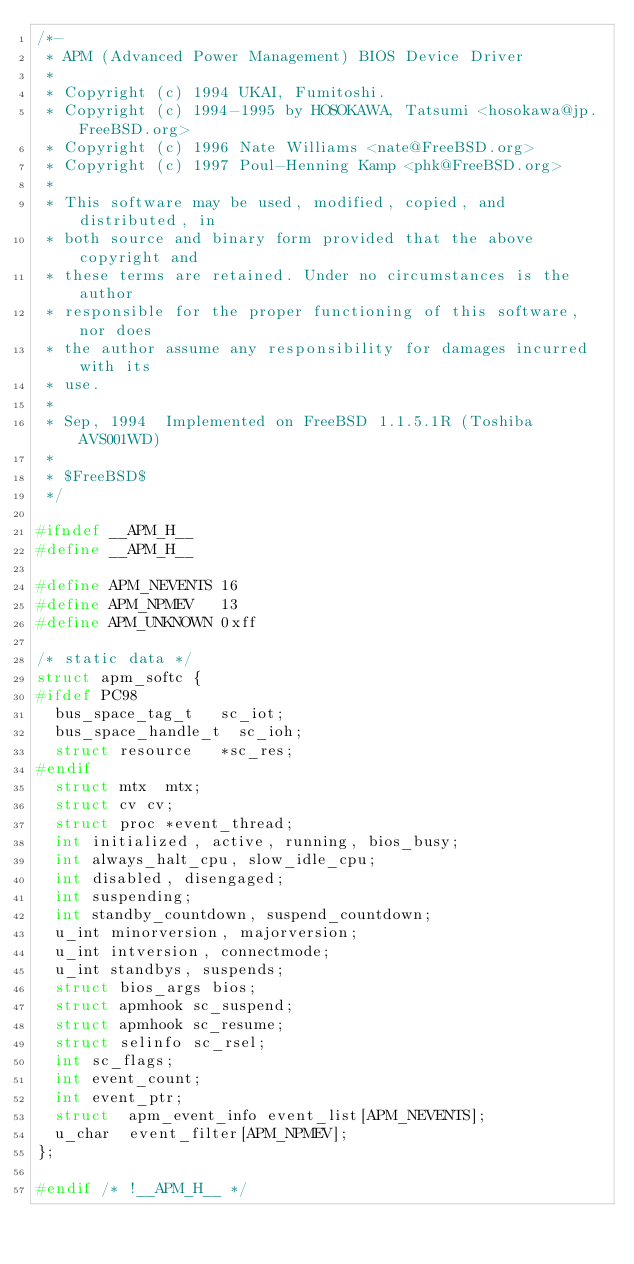Convert code to text. <code><loc_0><loc_0><loc_500><loc_500><_C_>/*-
 * APM (Advanced Power Management) BIOS Device Driver
 *
 * Copyright (c) 1994 UKAI, Fumitoshi.
 * Copyright (c) 1994-1995 by HOSOKAWA, Tatsumi <hosokawa@jp.FreeBSD.org>
 * Copyright (c) 1996 Nate Williams <nate@FreeBSD.org>
 * Copyright (c) 1997 Poul-Henning Kamp <phk@FreeBSD.org>
 *
 * This software may be used, modified, copied, and distributed, in
 * both source and binary form provided that the above copyright and
 * these terms are retained. Under no circumstances is the author
 * responsible for the proper functioning of this software, nor does
 * the author assume any responsibility for damages incurred with its
 * use.
 *
 * Sep, 1994	Implemented on FreeBSD 1.1.5.1R (Toshiba AVS001WD)
 *
 * $FreeBSD$
 */

#ifndef __APM_H__
#define	__APM_H__

#define APM_NEVENTS 16
#define APM_NPMEV   13
#define APM_UNKNOWN	0xff

/* static data */
struct apm_softc {
#ifdef PC98
	bus_space_tag_t		sc_iot;
	bus_space_handle_t	sc_ioh;
	struct resource 	*sc_res;
#endif
	struct mtx	mtx;
	struct cv	cv;
	struct proc	*event_thread;
	int	initialized, active, running, bios_busy;
	int	always_halt_cpu, slow_idle_cpu;
	int	disabled, disengaged;
	int	suspending;
	int	standby_countdown, suspend_countdown;
	u_int	minorversion, majorversion;
	u_int	intversion, connectmode;
	u_int	standbys, suspends;
	struct bios_args bios;
	struct apmhook sc_suspend;
	struct apmhook sc_resume;
	struct selinfo sc_rsel;
	int	sc_flags;
	int	event_count;
	int	event_ptr;
	struct	apm_event_info event_list[APM_NEVENTS];
	u_char	event_filter[APM_NPMEV];
};

#endif /* !__APM_H__ */
</code> 